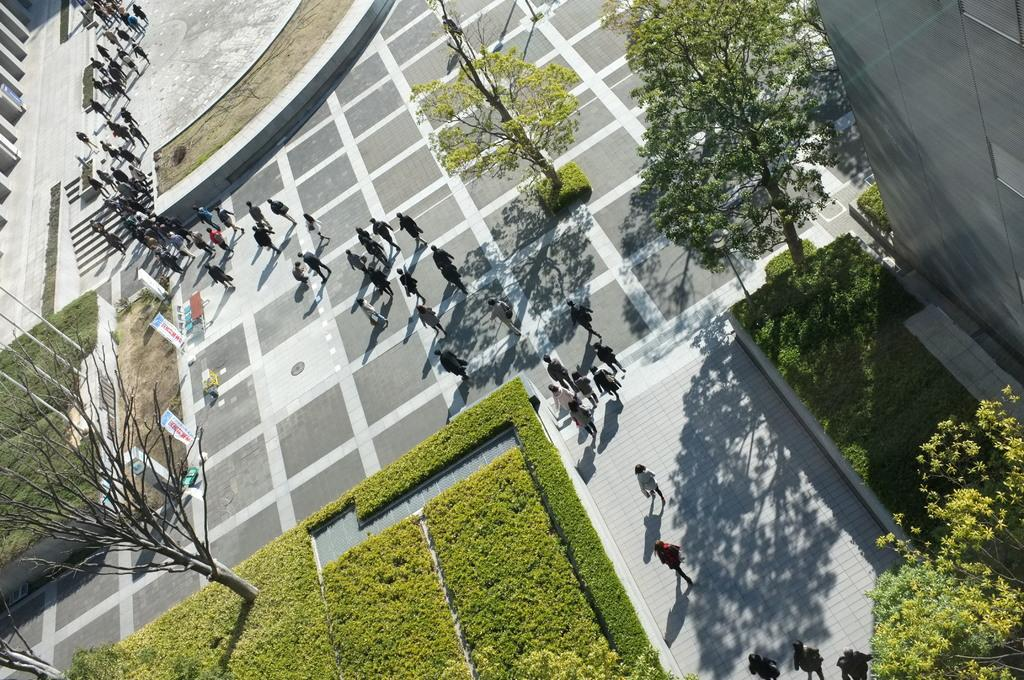What are the people in the image doing? The people in the image are walking. What type of vegetation can be seen in the image? There are trees and plants in the image. Can you describe any architectural features in the image? Yes, there is a staircase in the image. How many oranges are hanging from the trees in the image? There are no oranges visible in the image; only trees and plants can be seen. Can you tell me how many frogs are sitting on the staircase in the image? There are no frogs present in the image; only people walking, trees, plants, and a staircase can be seen. 